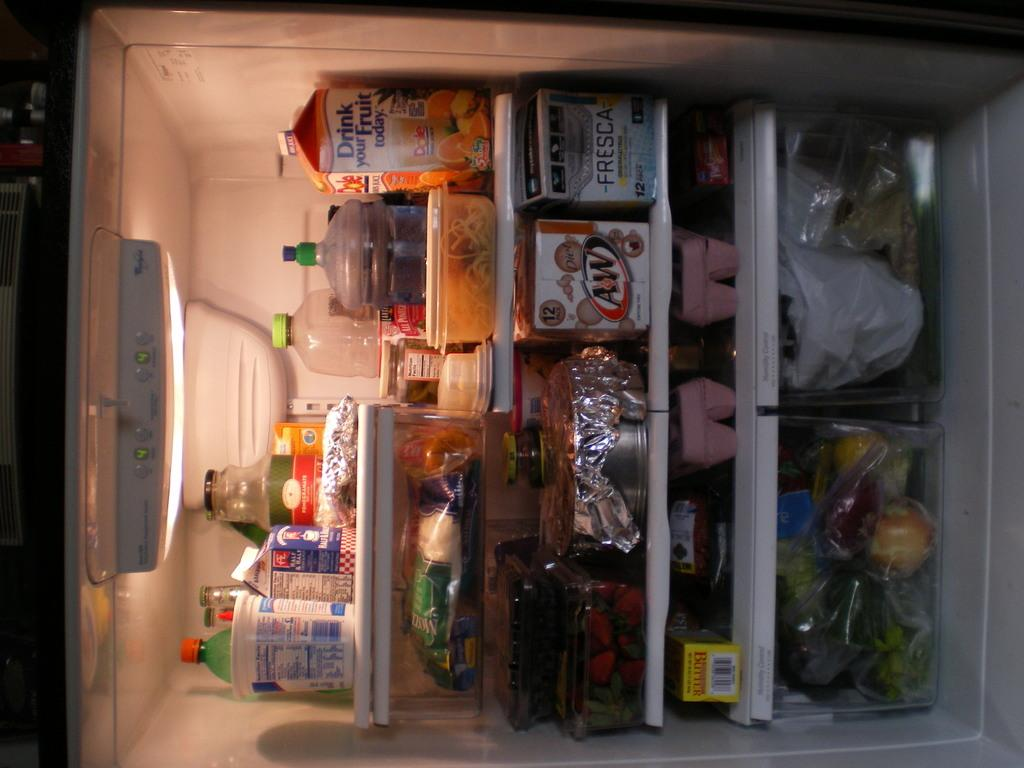<image>
Summarize the visual content of the image. a yellow box woith the word butter on it 